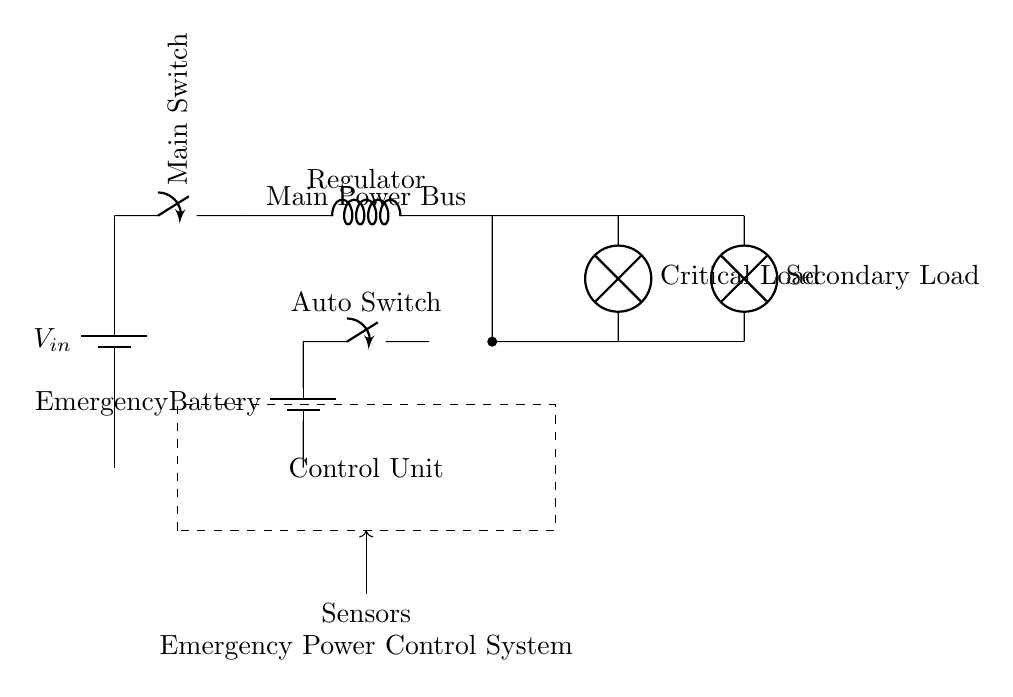What is the type of the main power source? The main power source in this circuit is a battery, specifically indicated by the label at the circuit symbol.
Answer: Battery What component regulates the output voltage? A cute inductor is shown in the diagram indicating that it serves as a voltage regulator to maintain a stable output.
Answer: Regulator What is the role of the emergency battery? The emergency battery provides backup power to ensure functionality during a power outage and is indicated by its specific labeling in the circuit.
Answer: Backup power How many loads are connected to the power distribution? There are two loads in the circuit: a Critical Load and a Secondary Load, as identified by the lamps shown in the circuit.
Answer: Two What type of switch is used to control the switch from the emergency battery? An auto switch is used in the circuit to automatically choose between the main power and the emergency battery when needed, as labeled in the diagram.
Answer: Auto Switch What is indicated by the dashed rectangle in the circuit? The dashed rectangle represents the control unit that manages the functionality of the various components in the circuit.
Answer: Control Unit Which component connects the critical load to the main power bus? The connection between the critical load and the main power bus is established through a lamp, which is the symbol representing the load.
Answer: Lamp 